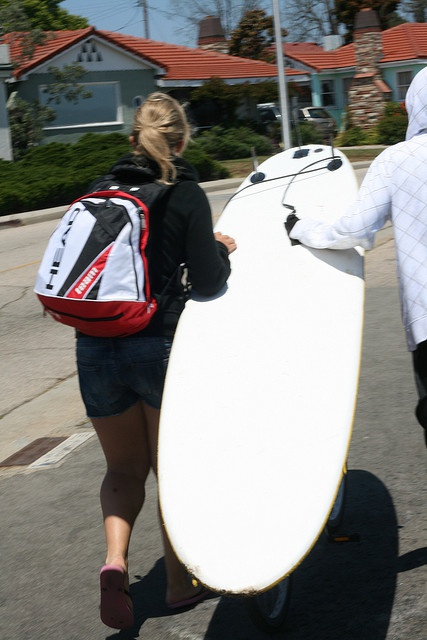Describe the objects in this image and their specific colors. I can see surfboard in darkgreen, white, darkgray, gray, and black tones, people in darkgreen, black, gray, and tan tones, backpack in darkgreen, lavender, black, maroon, and brown tones, people in darkgreen, lavender, black, darkgray, and gray tones, and car in darkgreen, black, and gray tones in this image. 